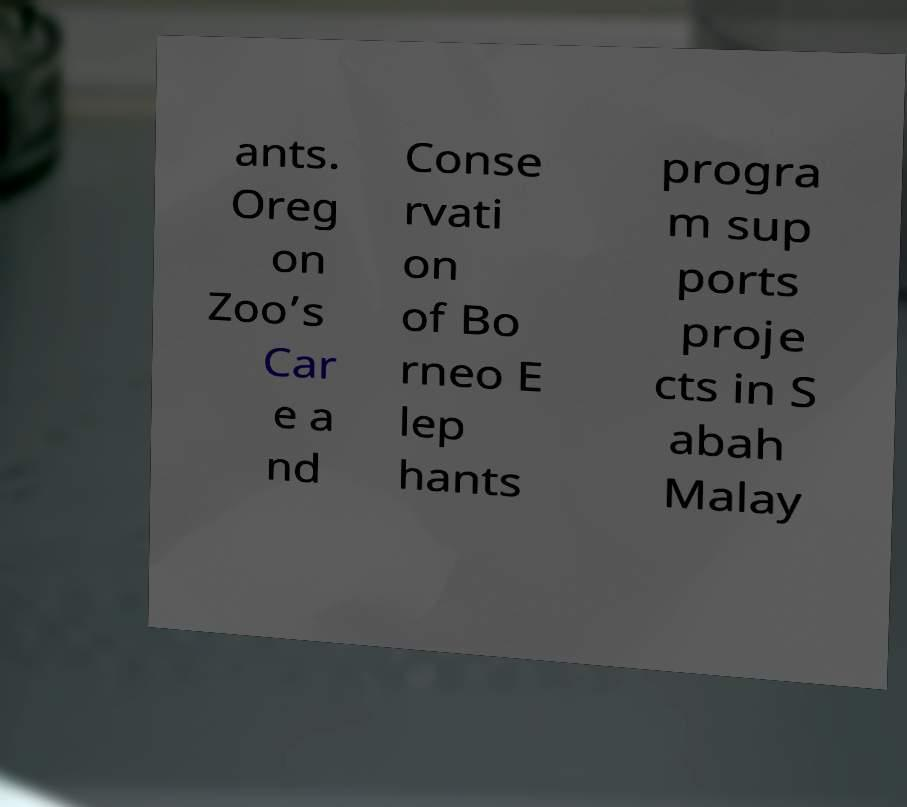Please read and relay the text visible in this image. What does it say? ants. Oreg on Zoo’s Car e a nd Conse rvati on of Bo rneo E lep hants progra m sup ports proje cts in S abah Malay 